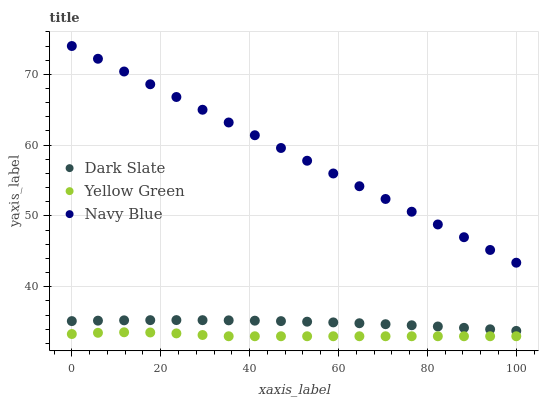Does Yellow Green have the minimum area under the curve?
Answer yes or no. Yes. Does Navy Blue have the maximum area under the curve?
Answer yes or no. Yes. Does Navy Blue have the minimum area under the curve?
Answer yes or no. No. Does Yellow Green have the maximum area under the curve?
Answer yes or no. No. Is Navy Blue the smoothest?
Answer yes or no. Yes. Is Yellow Green the roughest?
Answer yes or no. Yes. Is Yellow Green the smoothest?
Answer yes or no. No. Is Navy Blue the roughest?
Answer yes or no. No. Does Yellow Green have the lowest value?
Answer yes or no. Yes. Does Navy Blue have the lowest value?
Answer yes or no. No. Does Navy Blue have the highest value?
Answer yes or no. Yes. Does Yellow Green have the highest value?
Answer yes or no. No. Is Dark Slate less than Navy Blue?
Answer yes or no. Yes. Is Dark Slate greater than Yellow Green?
Answer yes or no. Yes. Does Dark Slate intersect Navy Blue?
Answer yes or no. No. 